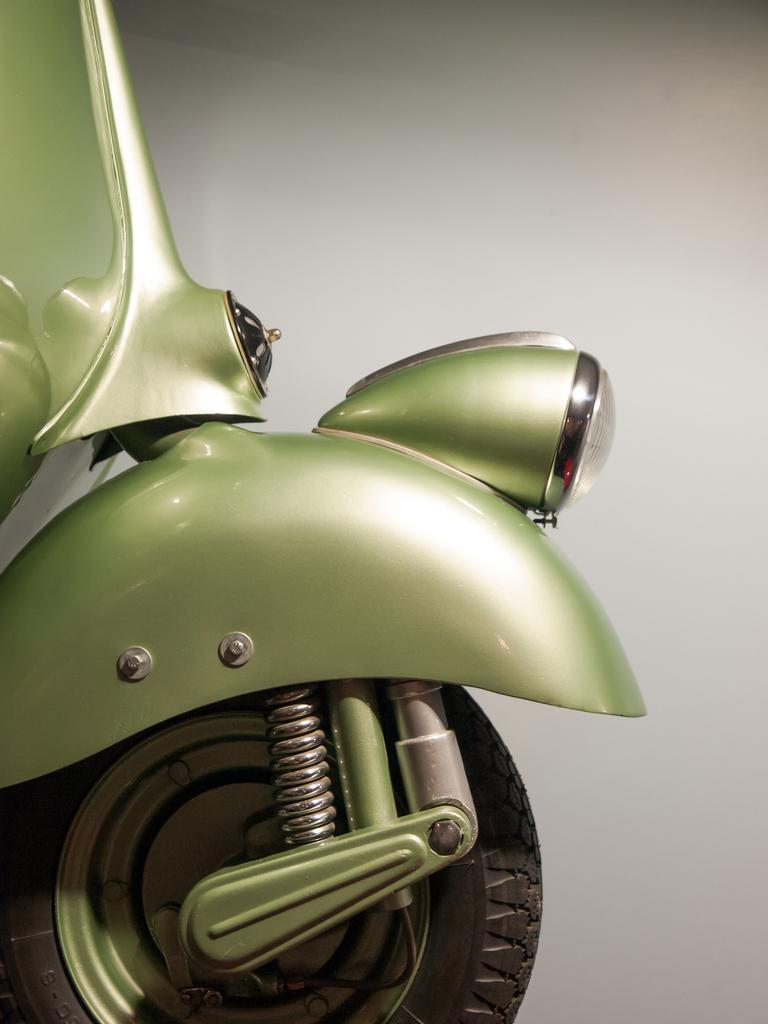What type of object is the main subject of the image? There is a vehicle in the image. Which part of the vehicle can be seen in the image? The front part of the vehicle is visible. Can you identify any specific features of the vehicle? There is a wheel visible in the image. What type of flower is growing near the vehicle in the image? There is no flower present in the image; it only features a vehicle with a visible wheel. 